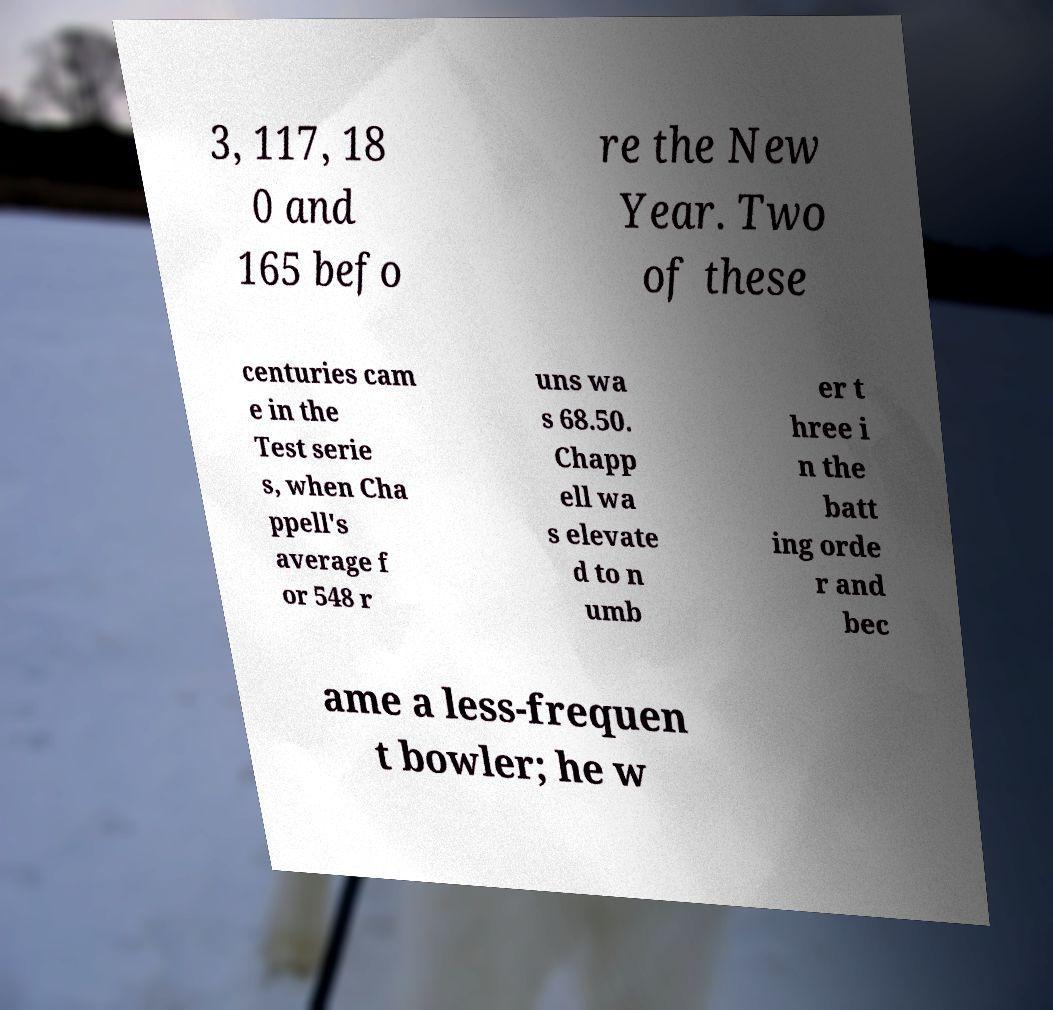I need the written content from this picture converted into text. Can you do that? 3, 117, 18 0 and 165 befo re the New Year. Two of these centuries cam e in the Test serie s, when Cha ppell's average f or 548 r uns wa s 68.50. Chapp ell wa s elevate d to n umb er t hree i n the batt ing orde r and bec ame a less-frequen t bowler; he w 